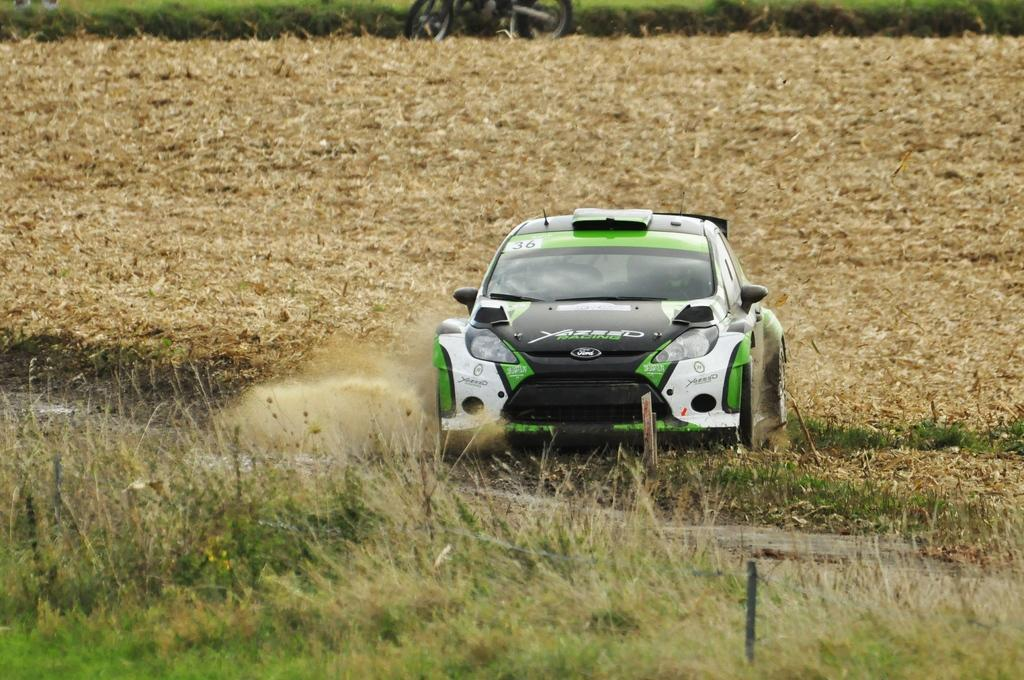What type of vehicle is in the image? There is a car in the image. How is the car positioned in the image? The car is placed on the ground. What type of vegetation can be seen in the image? There is grass visible in the image. What other objects can be seen in the image? There are poles and a motorbike parked in the image. What type of pets are sitting on the cloth in the image? There are no pets or cloth present in the image. How many books can be seen on the ground in the image? There are no books visible in the image. 